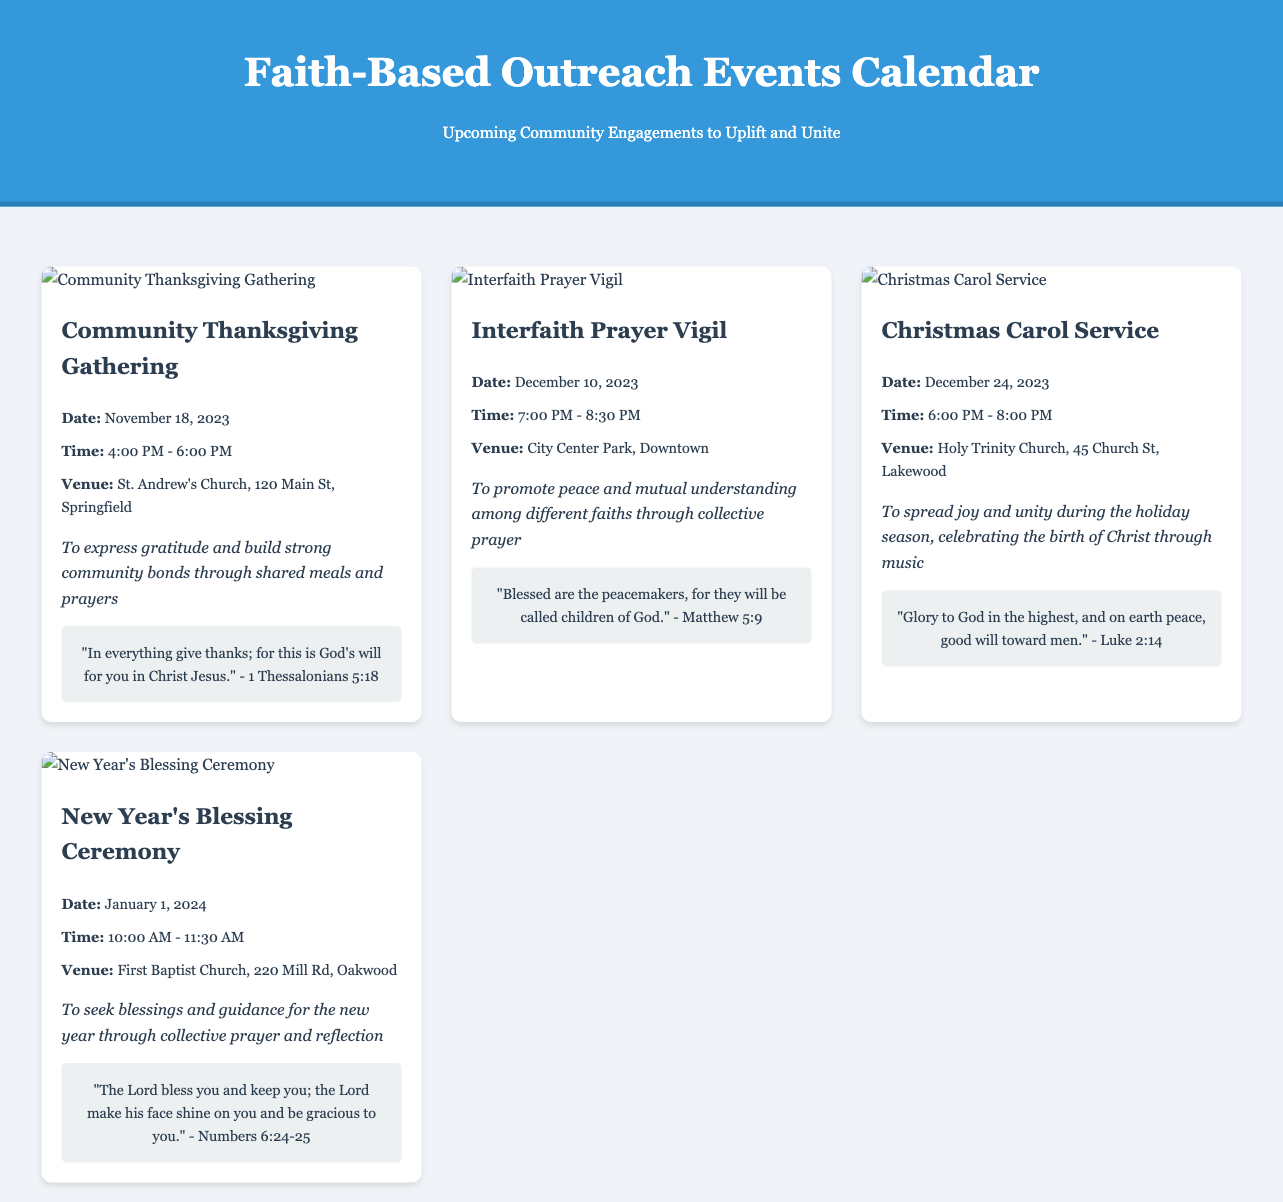What is the date of the Community Thanksgiving Gathering? The date is specified in the document under the event details for the Community Thanksgiving Gathering.
Answer: November 18, 2023 What venue will host the Interfaith Prayer Vigil? The venue is listed in the document under the event information for the Interfaith Prayer Vigil.
Answer: City Center Park, Downtown How long will the Christmas Carol Service last? The time duration can be inferred by subtracting the start time from the end time listed for the Christmas Carol Service.
Answer: 2 hours What is the goal of the New Year's Blessing Ceremony? The goal is articulated in the event details for the New Year's Blessing Ceremony in the document.
Answer: To seek blessings and guidance for the new year through collective prayer and reflection Which inspirational quote is associated with the Christmas Carol Service? The quote can be found in the document within the Christmas Carol Service event details.
Answer: "Glory to God in the highest, and on earth peace, good will toward men." - Luke 2:14 What is the time for the Interfaith Prayer Vigil? The time is mentioned in the event information for the Interfaith Prayer Vigil in the document.
Answer: 7:00 PM - 8:30 PM How many events are highlighted in the document? The number of event cards in the document indicates the total events highlighted.
Answer: 4 events What image is shown for the Community Thanksgiving Gathering? The image source is shown in the document under the Community Thanksgiving Gathering event card.
Answer: https://example.com/images/thanksgiving_gathering.jpg 